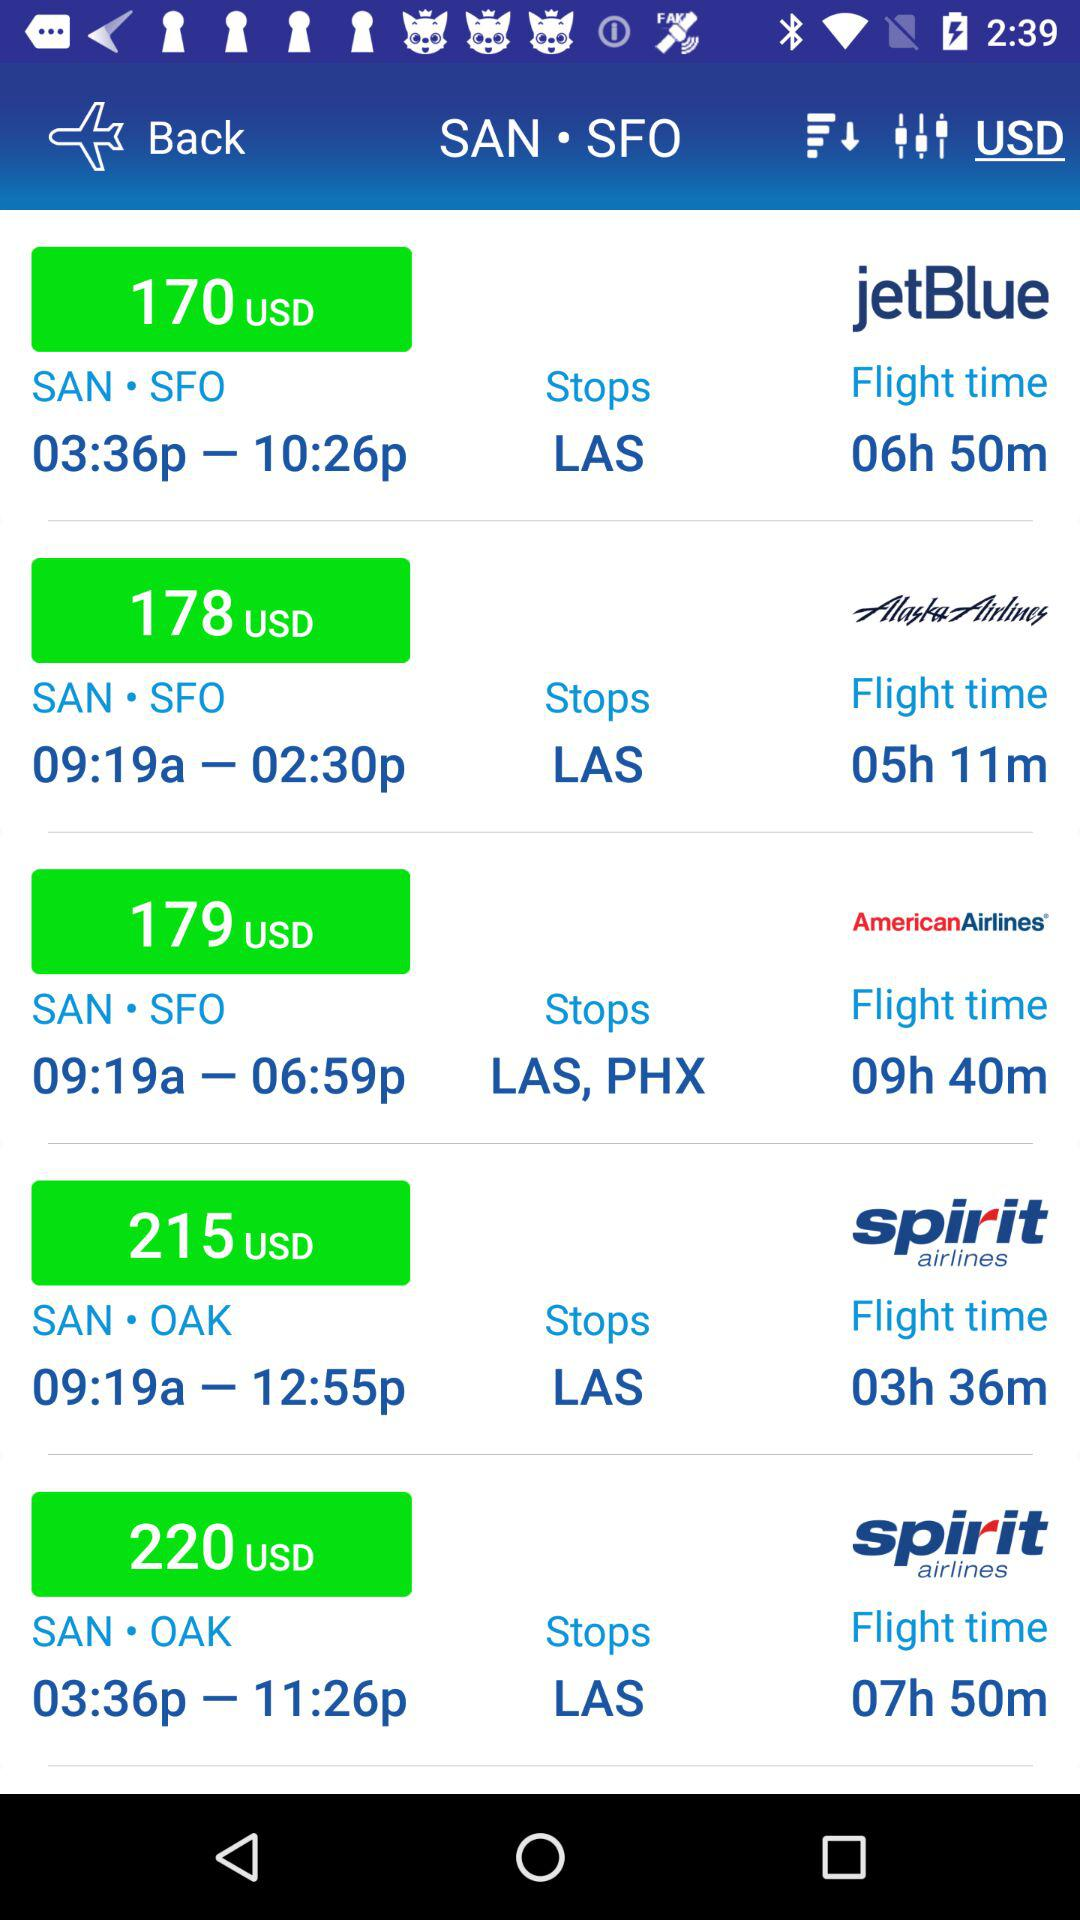What is the currency of the price? The currency of the price is USD. 